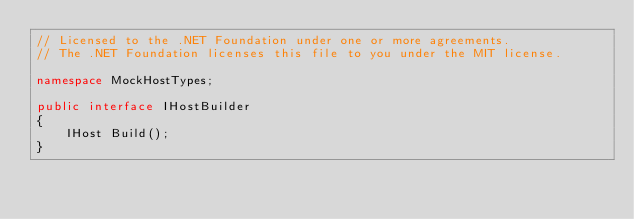Convert code to text. <code><loc_0><loc_0><loc_500><loc_500><_C#_>// Licensed to the .NET Foundation under one or more agreements.
// The .NET Foundation licenses this file to you under the MIT license.

namespace MockHostTypes;

public interface IHostBuilder
{
    IHost Build();
}
</code> 